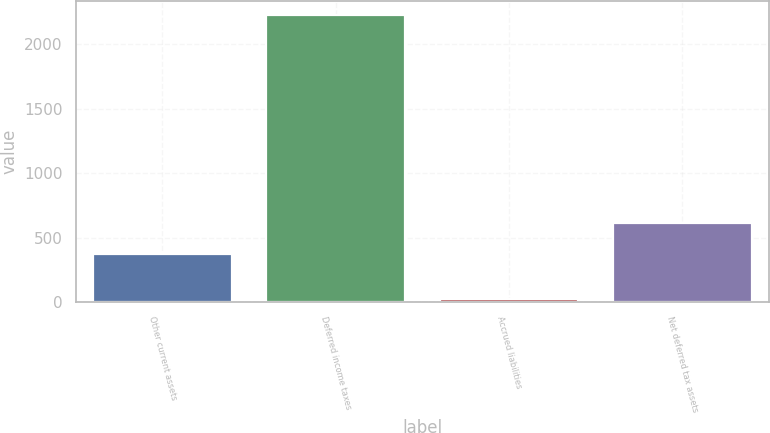<chart> <loc_0><loc_0><loc_500><loc_500><bar_chart><fcel>Other current assets<fcel>Deferred income taxes<fcel>Accrued liabilities<fcel>Net deferred tax assets<nl><fcel>372<fcel>2222<fcel>21<fcel>610.8<nl></chart> 